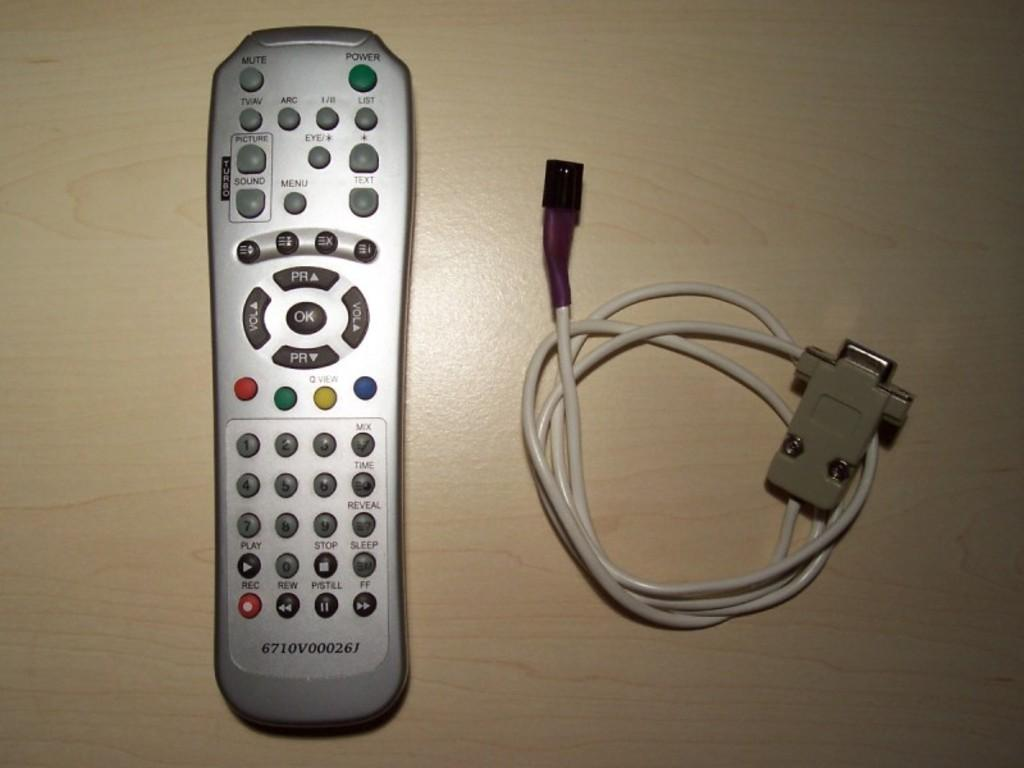<image>
Render a clear and concise summary of the photo. A remote control has a POWER and MUTE button up on the top. 